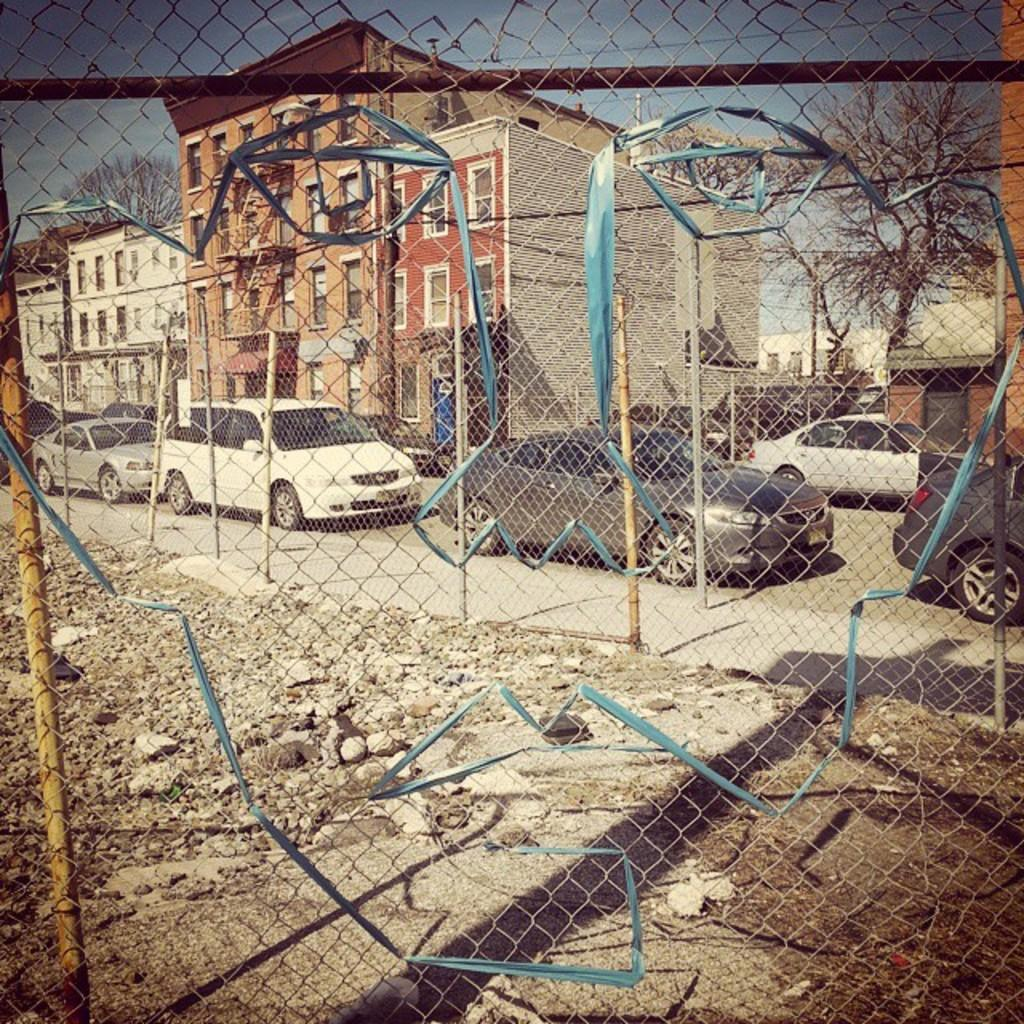What type of barrier can be seen in the image? There is a fence in the image. What is happening on the road in the image? There are vehicles on the road in the image. What can be seen in the distance in the image? There are buildings and trees visible in the background of the image. What else is visible in the background of the image? The sky is visible in the background of the image. What type of creature is being educated by the mother in the image? There is no creature or mother present in the image. What type of education is being provided in the image? There is no educational activity depicted in the image. 